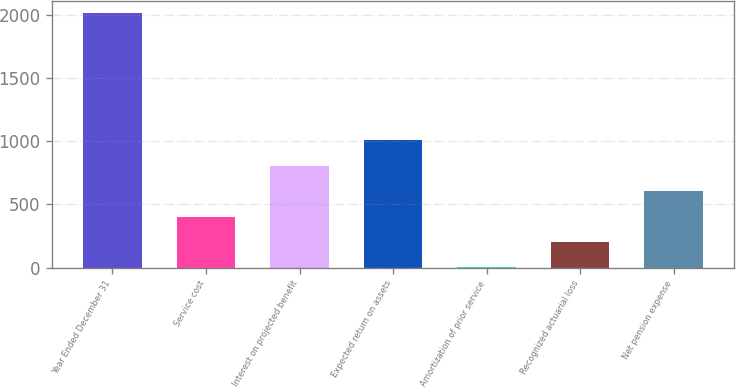Convert chart to OTSL. <chart><loc_0><loc_0><loc_500><loc_500><bar_chart><fcel>Year Ended December 31<fcel>Service cost<fcel>Interest on projected benefit<fcel>Expected return on assets<fcel>Amortization of prior service<fcel>Recognized actuarial loss<fcel>Net pension expense<nl><fcel>2013<fcel>403.64<fcel>805.98<fcel>1007.15<fcel>1.3<fcel>202.47<fcel>604.81<nl></chart> 